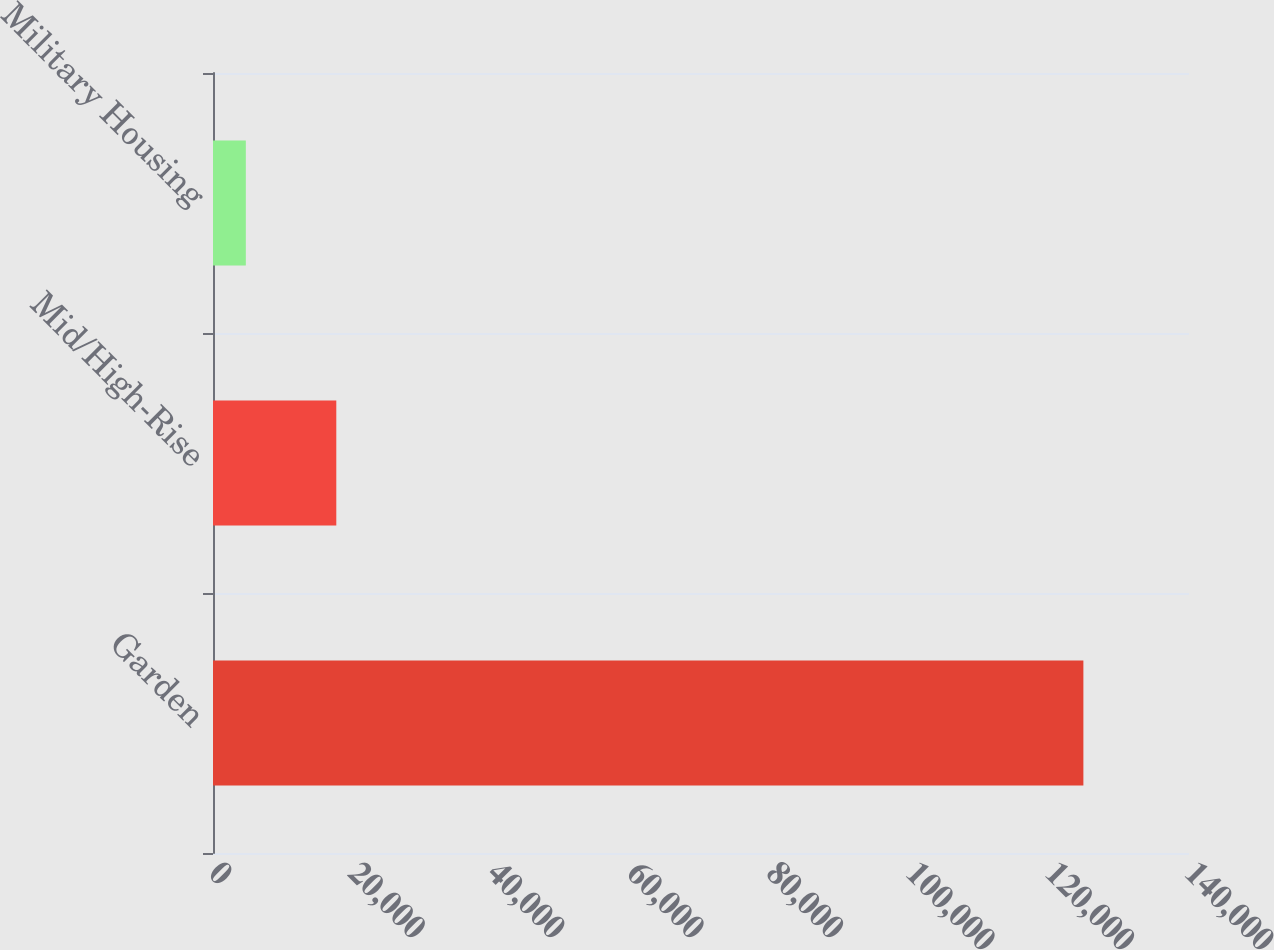Convert chart to OTSL. <chart><loc_0><loc_0><loc_500><loc_500><bar_chart><fcel>Garden<fcel>Mid/High-Rise<fcel>Military Housing<nl><fcel>124850<fcel>17685<fcel>4709<nl></chart> 